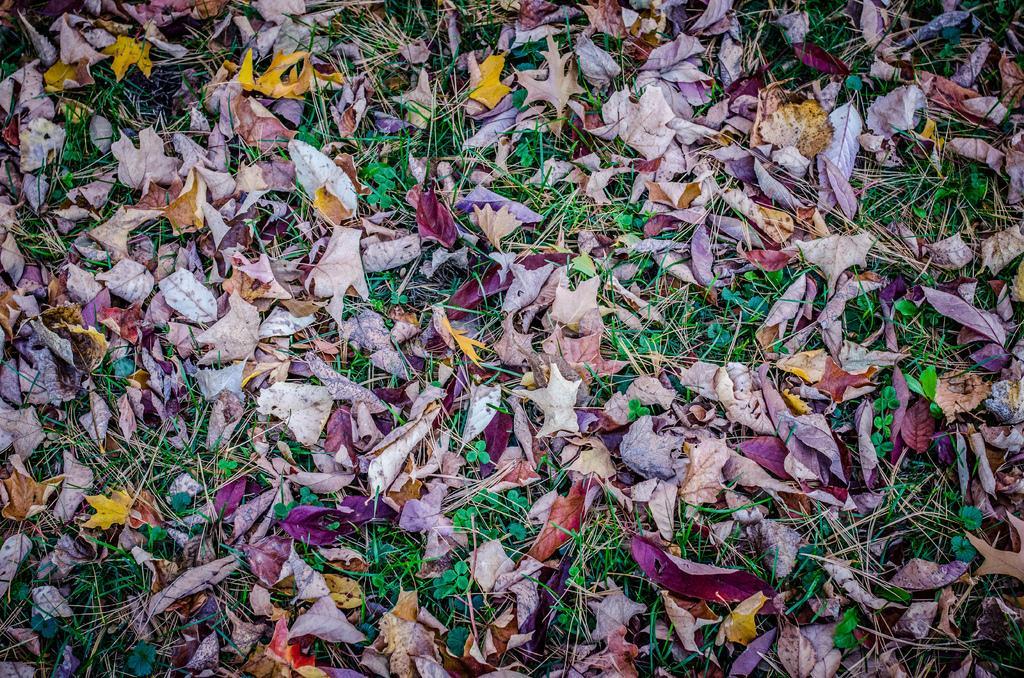In one or two sentences, can you explain what this image depicts? In this image I can see many dry leaves, grass and few plants on the ground. 